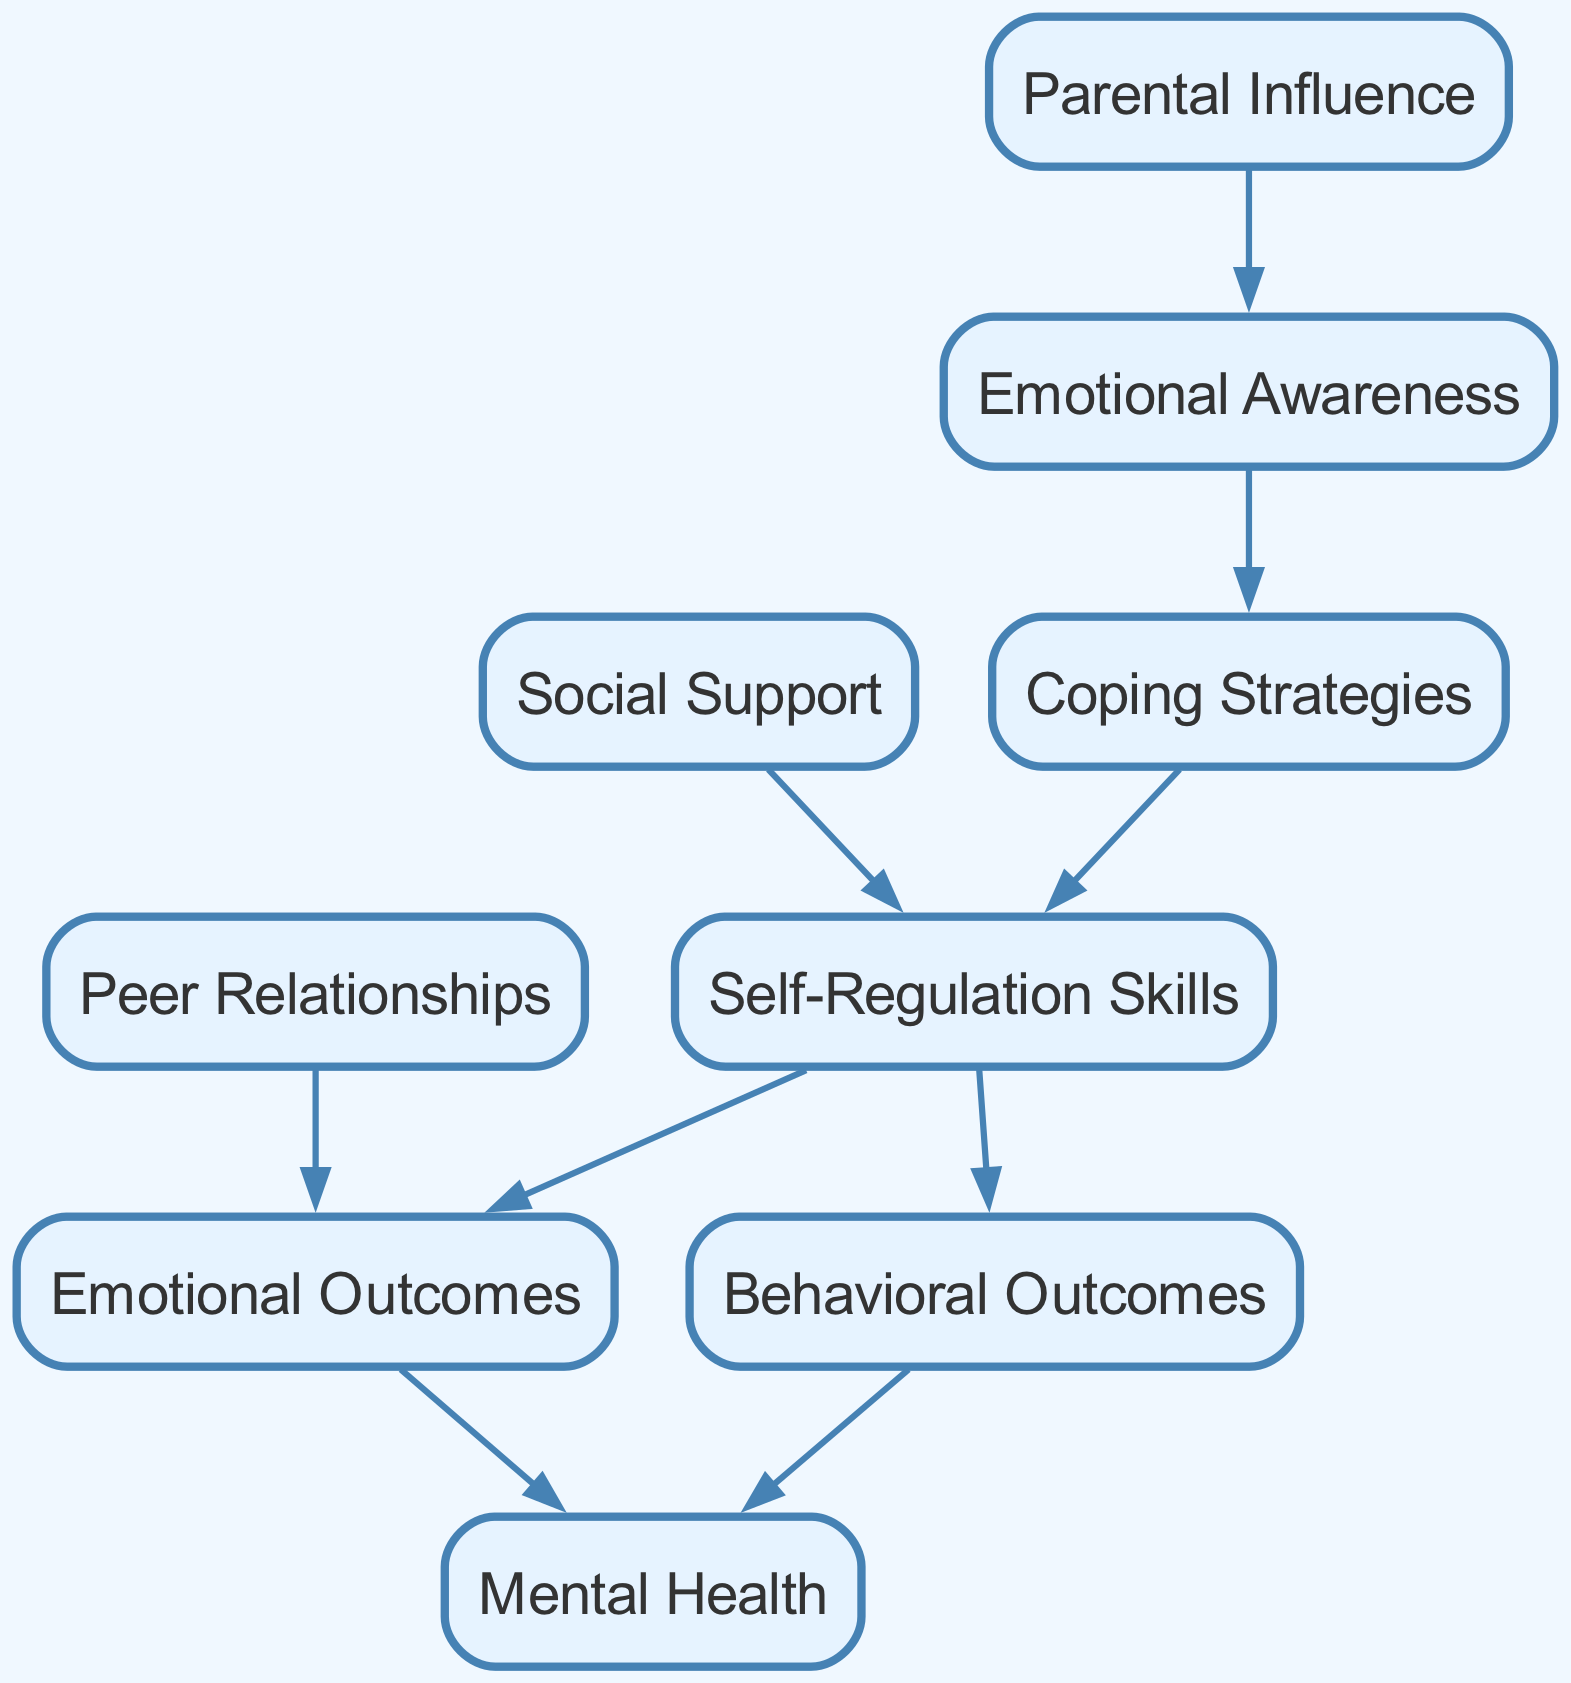What is the total number of nodes in the diagram? The diagram has 9 distinct nodes listed: Emotional Awareness, Coping Strategies, Social Support, Self-Regulation Skills, Parental Influence, Peer Relationships, Emotional Outcomes, Behavioral Outcomes, and Mental Health. Therefore, counting these gives a total of 9 nodes.
Answer: 9 Which node influences Self-Regulation Skills? There are two nodes that have direct edges pointing to Self-Regulation Skills: Coping Strategies and Social Support. This means that both Coping Strategies and Social Support influence Self-Regulation Skills.
Answer: Coping Strategies, Social Support What is the outcome of Emotional Outcomes in the diagram? Emotional Outcomes directly affects one node, which is Mental Health, as there is a directed edge from Emotional Outcomes to Mental Health. This signifies that Emotional Outcomes have an impact on Mental Health.
Answer: Mental Health How many edges are present in this diagram? To count the edges, we examine the directed connections (edges) between the nodes. There are 8 distinct edges listed in the diagram, connecting the various nodes.
Answer: 8 Which node has the highest influence leading to Mental Health? Both Emotional Outcomes and Behavioral Outcomes influence Mental Health, showing that they lead to it. Although they are equal in terms of direct influence, if we consider immediate predecessors, both would be counted. Therefore, the influence comes from two distinct nodes.
Answer: Emotional Outcomes, Behavioral Outcomes What is the relationship between Parental Influence and Emotional Awareness? There is a directed edge from Parental Influence to Emotional Awareness, which indicates that Parental Influence directly leads to Emotional Awareness, suggesting that parenting behaviors or attitudes can enhance children's emotional awareness.
Answer: Direct influence Which node serves as the starting point for emotional regulation strategies? The starting point, or first step in the pathway of emotional regulation strategies, is Emotional Awareness, as it has no incoming edges and serves as a foundation for subsequent strategies.
Answer: Emotional Awareness Which two nodes lead to Behavioral Outcomes? Self-Regulation Skills is the only node that leads to Behavioral Outcomes, demonstrating a direct pathway from Self-Regulation Skills to Behavioral Outcomes in the diagram.
Answer: Self-Regulation Skills What is the connection between Peer Relationships and Emotional Outcomes? Peer Relationships lead to Emotional Outcomes since there is a directed edge from Peer Relationships to Emotional Outcomes, which suggests that social interactions with peers can impact emotional states.
Answer: Influences How does Social Support influence emotional regulation? Social Support influences emotional regulation by leading to the development of Self-Regulation Skills through a directed edge, indicating that having social support helps children better regulate their emotions.
Answer: Leads to Self-Regulation Skills 